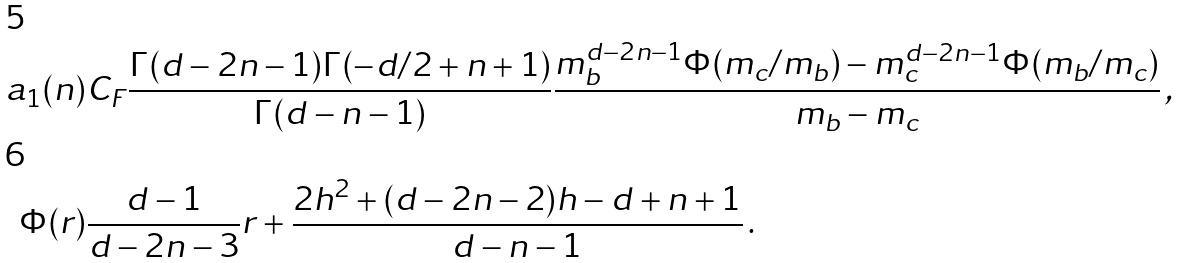<formula> <loc_0><loc_0><loc_500><loc_500>a _ { 1 } ( n ) & C _ { F } \frac { \Gamma ( d - 2 n - 1 ) \Gamma ( - d / 2 + n + 1 ) } { \Gamma ( d - n - 1 ) } \frac { m _ { b } ^ { d - 2 n - 1 } \Phi ( m _ { c } / m _ { b } ) - m _ { c } ^ { d - 2 n - 1 } \Phi ( m _ { b } / m _ { c } ) } { m _ { b } - m _ { c } } \, , \\ \Phi ( r ) & \frac { d - 1 } { d - 2 n - 3 } r + \frac { 2 h ^ { 2 } + ( d - 2 n - 2 ) h - d + n + 1 } { d - n - 1 } \, .</formula> 